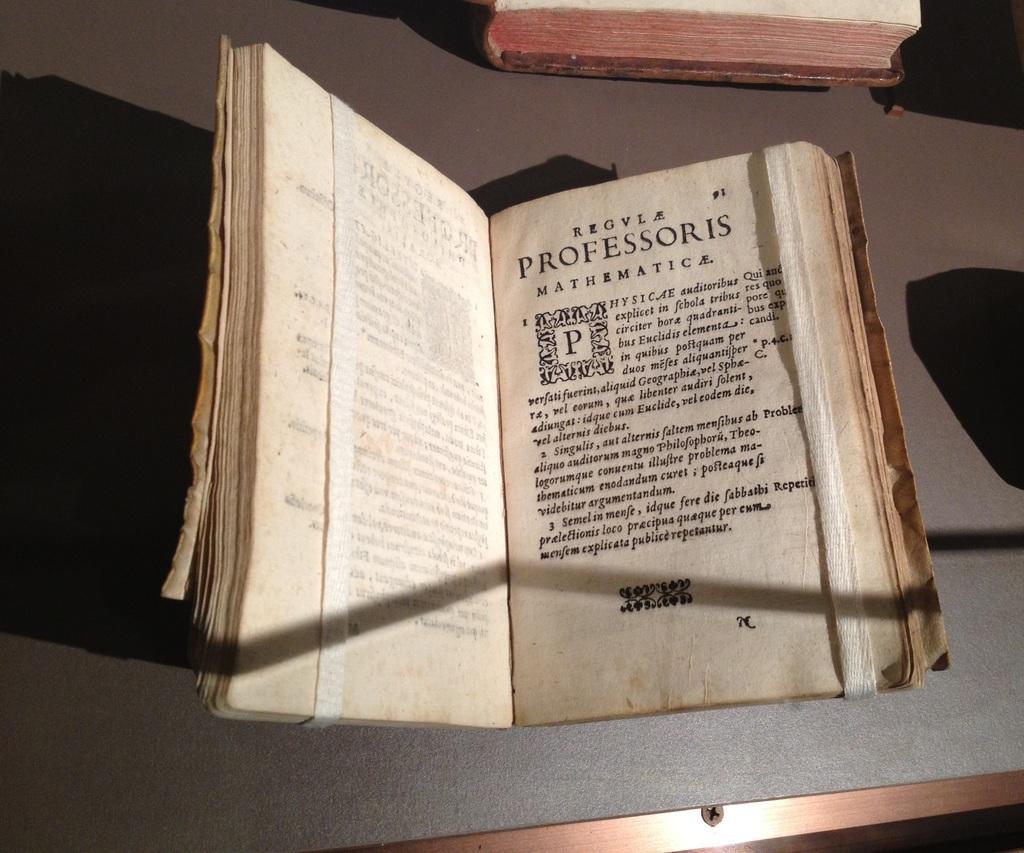In one or two sentences, can you explain what this image depicts? In this image I see 2 books and over here I see number of words written on this paper and I see that these 2 books are on the brown color surface and I see the shadows. 